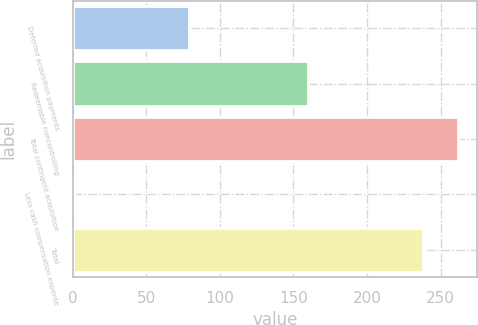Convert chart. <chart><loc_0><loc_0><loc_500><loc_500><bar_chart><fcel>Deferred acquisition payments<fcel>Redeemable noncontrolling<fcel>Total contingent acquisition<fcel>Less cash compensation expense<fcel>Total<nl><fcel>79<fcel>160.1<fcel>261.8<fcel>1.1<fcel>238<nl></chart> 